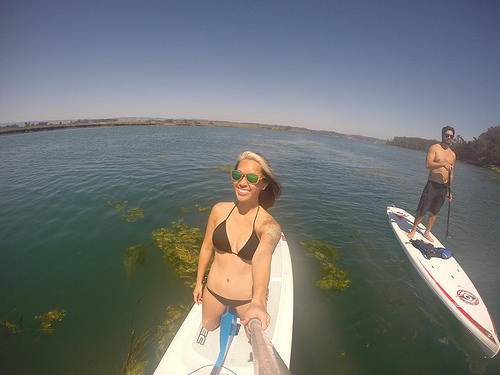<image>
Is there a man on the boat? Yes. Looking at the image, I can see the man is positioned on top of the boat, with the boat providing support. Is there a lady in the water? No. The lady is not contained within the water. These objects have a different spatial relationship. Is there a glass in front of the dark? No. The glass is not in front of the dark. The spatial positioning shows a different relationship between these objects. 